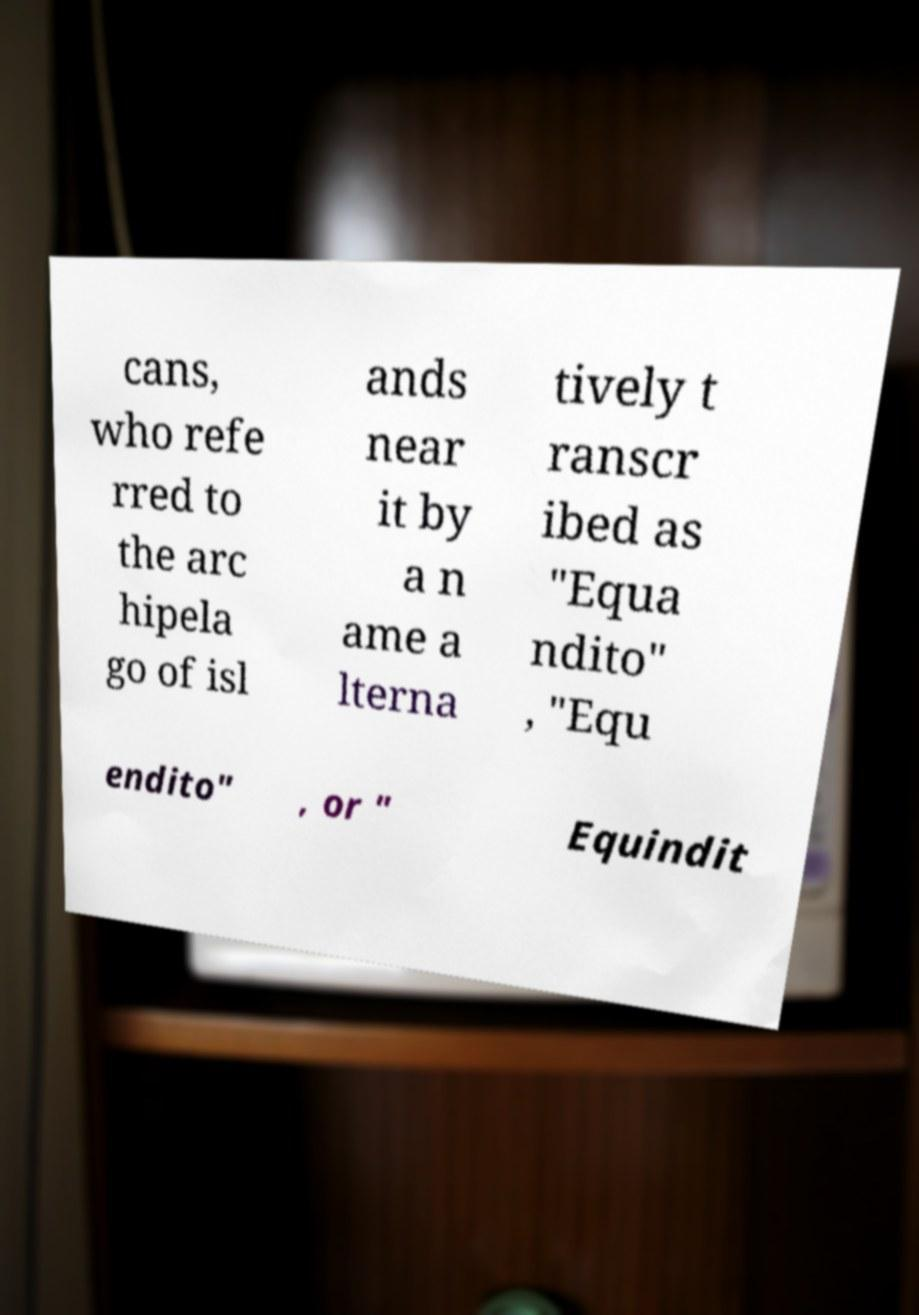Can you accurately transcribe the text from the provided image for me? cans, who refe rred to the arc hipela go of isl ands near it by a n ame a lterna tively t ranscr ibed as "Equa ndito" , "Equ endito" , or " Equindit 